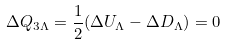<formula> <loc_0><loc_0><loc_500><loc_500>\Delta Q _ { 3 \Lambda } = { \frac { 1 } { 2 } } ( \Delta U _ { \Lambda } - \Delta D _ { \Lambda } ) = 0</formula> 